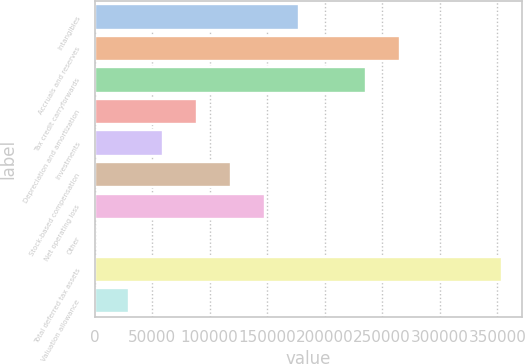Convert chart. <chart><loc_0><loc_0><loc_500><loc_500><bar_chart><fcel>Intangibles<fcel>Accruals and reserves<fcel>Tax credit carryforwards<fcel>Depreciation and amortization<fcel>Investments<fcel>Stock-based compensation<fcel>Net operating loss<fcel>Other<fcel>Total deferred tax assets<fcel>Valuation allowance<nl><fcel>177303<fcel>265752<fcel>236269<fcel>88854.7<fcel>59371.8<fcel>118338<fcel>147820<fcel>406<fcel>354201<fcel>29888.9<nl></chart> 